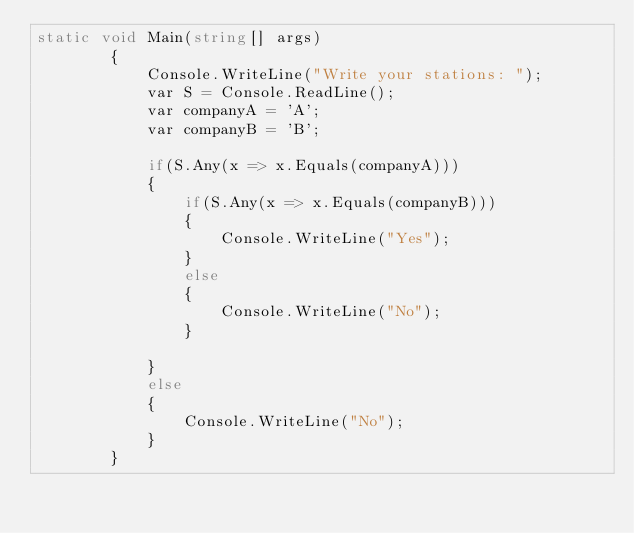<code> <loc_0><loc_0><loc_500><loc_500><_C#_>static void Main(string[] args)
        {
            Console.WriteLine("Write your stations: ");
            var S = Console.ReadLine();
            var companyA = 'A';
            var companyB = 'B';

            if(S.Any(x => x.Equals(companyA)))
            {
                if(S.Any(x => x.Equals(companyB)))
                {
                    Console.WriteLine("Yes");
                }
                else
                {
                    Console.WriteLine("No");
                }
                
            }
            else
            {
                Console.WriteLine("No");
            }
        }</code> 